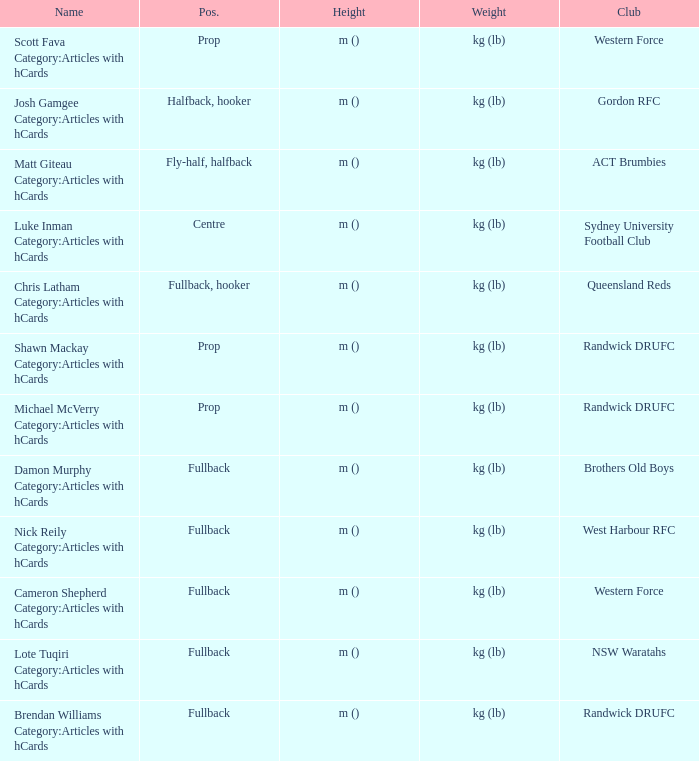What is the title when the place is at the center? Luke Inman Category:Articles with hCards. 